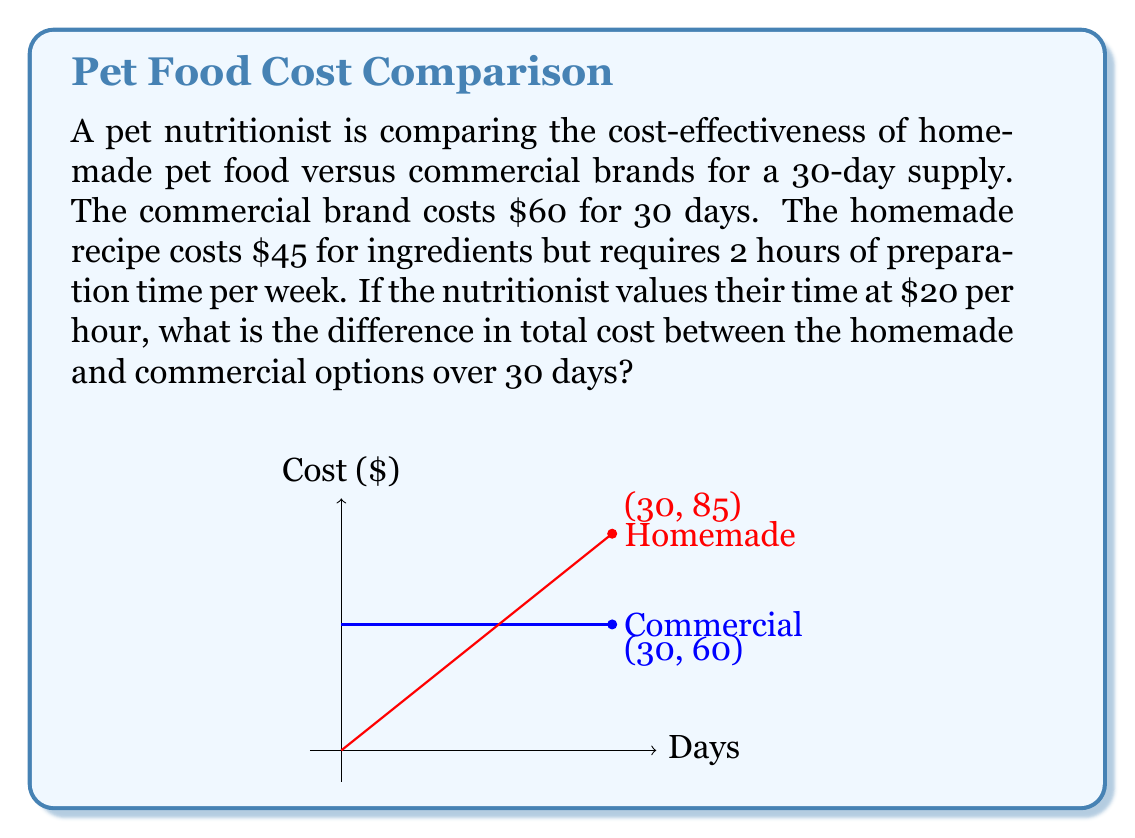Can you solve this math problem? Let's break this down step-by-step:

1) First, calculate the cost of homemade food:
   - Ingredient cost: $45
   - Time cost: 2 hours/week * 4.3 weeks (30 days) * $20/hour = $172
   - Total homemade cost: $45 + $172 = $217

2) Commercial food cost is given as $60 for 30 days.

3) Calculate the difference:
   $$ \text{Difference} = \text{Homemade cost} - \text{Commercial cost} $$
   $$ = $217 - $60 = $157 $$

Therefore, the homemade option costs $157 more than the commercial option over 30 days when accounting for the nutritionist's time.
Answer: $157 